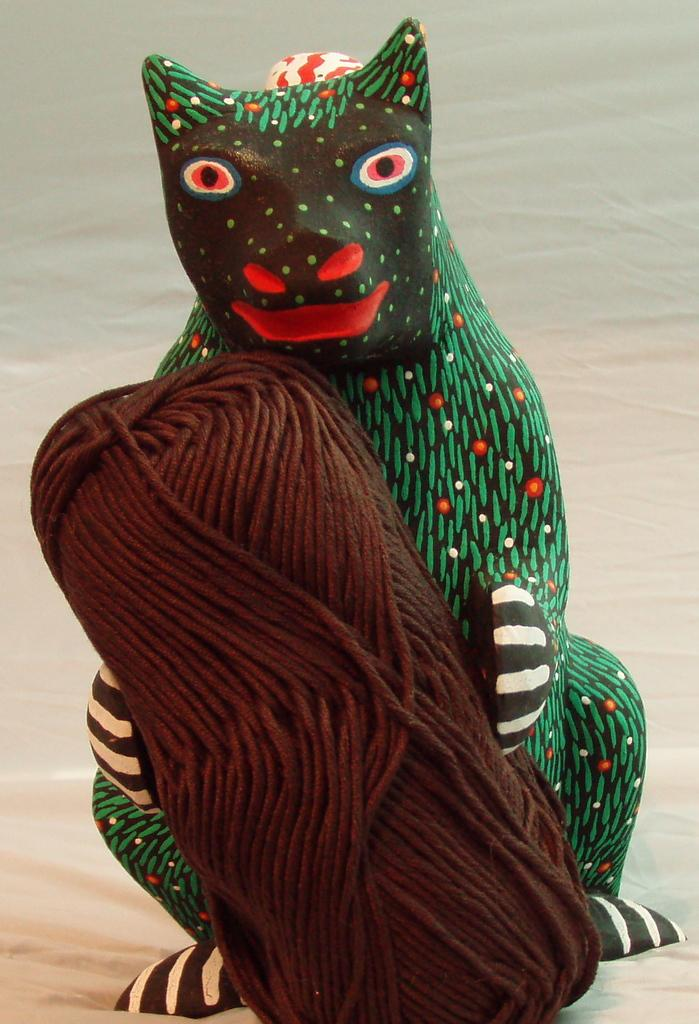What object is present in the image that resembles a human figure? There is a plastic doll in the image. What is the doll holding in its hand? The doll is holding a thread. What piece of furniture can be seen in the image? There is a bed visible in the image. Where is the nest located in the image? There is no nest present in the image. What type of crack can be seen on the doll's face in the image? There is no crack visible on the doll's face in the image. 